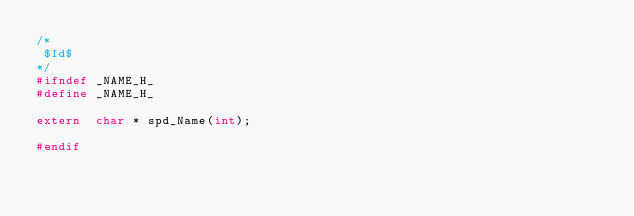Convert code to text. <code><loc_0><loc_0><loc_500><loc_500><_C_>/*
 $Id$
*/
#ifndef	_NAME_H_
#define _NAME_H_

extern	char * spd_Name(int);

#endif
</code> 